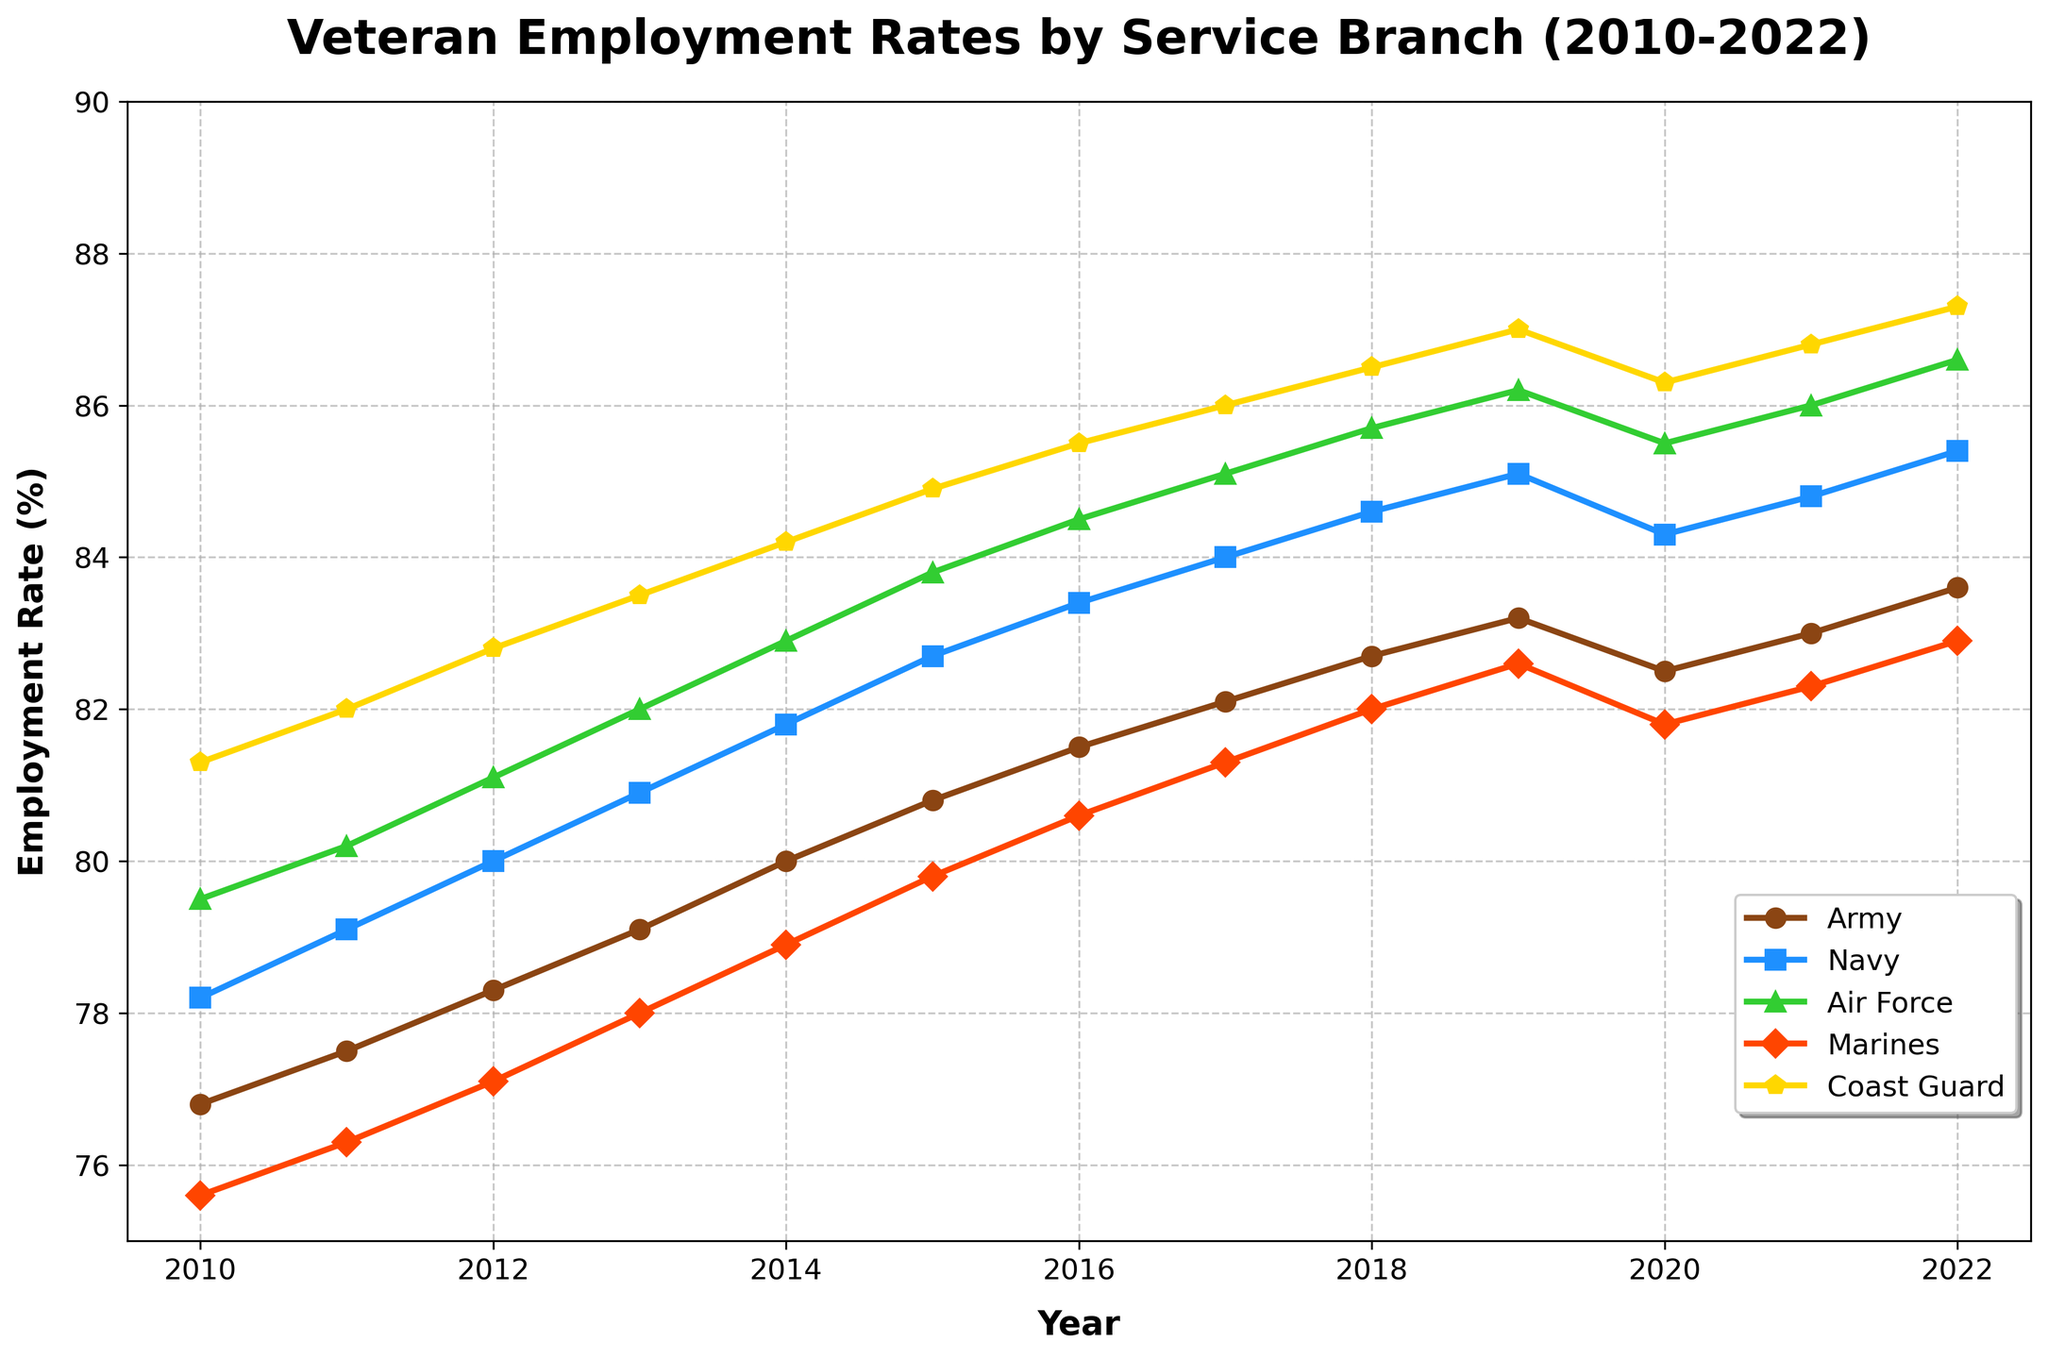Which service branch had the highest employment rate in 2013? To determine which branch had the highest employment rate in 2013, look at the y-values for each line at the x-value corresponding to 2013. The highest y-value indicates the branch with the highest employment rate. The Coast Guard line has the highest value.
Answer: Coast Guard What was the average employment rate for the Army between 2010 and 2022? First, note the employment rates for the Army each year from 2010 to 2022: 76.8, 77.5, 78.3, 79.1, 80.0, 80.8, 81.5, 82.1, 82.7, 83.2, 82.5, 83.0, and 83.6. Add these rates together and divide by the number of years: (76.8 + 77.5 + 78.3 + 79.1 + 80.0 + 80.8 + 81.5 + 82.1 + 82.7 + 83.2 + 82.5 + 83.0 + 83.6) / 13 = 80.96
Answer: 80.96 In which year did the Navy surpass an employment rate of 85%? Find where the Navy’s employment rate line crosses the 85% mark on the y-axis. The Navy crosses 85% in 2019.
Answer: 2019 Which branch shows the most consistent rise in employment rates without any declines from 2010 to 2022? To determine this, look at the trends of each branch's line over time. The Air Force line shows a consistent rise without any downward trends from 2010 to 2022.
Answer: Air Force By how many percentage points did the Marine's employment rate increase from 2010 to 2022? Note the Marine's employment rates in 2010 and 2022: 75.6% and 82.9%. Calculate the difference: 82.9 - 75.6 = 7.3 percentage points.
Answer: 7.3 Compare the difference in employment rates between the Army and Navy in 2020. Note the employment rates for the Army and Navy in 2020: the Army is 82.5% and the Navy is 84.3%. Calculate the difference: 84.3 - 82.5 = 1.8 percentage points.
Answer: 1.8 Which branch had the lowest employment rate in 2016? Determine the lowest rate among all branches in 2016 by comparing the y-values on the figure for each branch. The Marines had the lowest rate at 80.6%.
Answer: Marines What visual attribute distinguishes the Marines' employment rate trend on the chart? Observe the visual representation of the Marines' employment rate. The line is marked with triangle markers (^) and is colored in bright red.
Answer: Red line with triangle markers What is the employment rate trend for the Coast Guard from 2010 to 2022? Look at the Coast Guard line on the chart. The trend shows a general upward trajectory from 2010 to 2022, with slight fluctuations around 2020.
Answer: Upward trend Which branch had a dip in employment rate around 2020? Identify the lines that show a noticeable drop around the year 2020. Both the Army and Air Force show dips in employment rates around that year.
Answer: Army, Air Force 